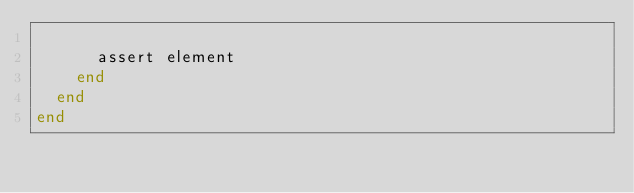Convert code to text. <code><loc_0><loc_0><loc_500><loc_500><_Elixir_>
      assert element
    end
  end
end
</code> 